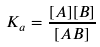Convert formula to latex. <formula><loc_0><loc_0><loc_500><loc_500>K _ { a } = \frac { [ A ] [ B ] } { [ A B ] }</formula> 